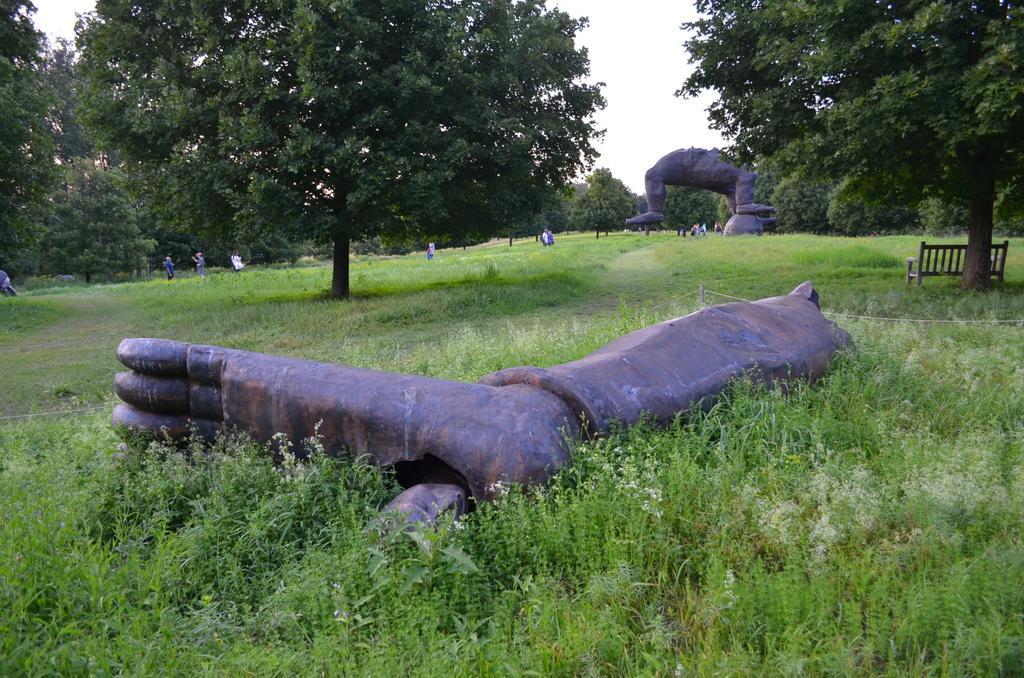How would you summarize this image in a sentence or two? In the center of the image there is a depiction of persons leg. At the bottom of the image there are plants. In the background of the image there are trees. There is sky. To the right side of the image there is a bench. 